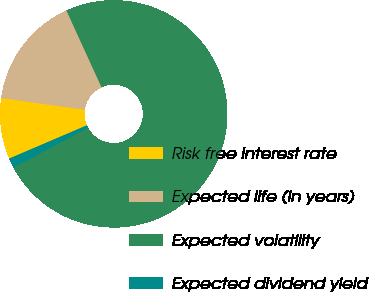<chart> <loc_0><loc_0><loc_500><loc_500><pie_chart><fcel>Risk free interest rate<fcel>Expected life (in years)<fcel>Expected volatility<fcel>Expected dividend yield<nl><fcel>8.67%<fcel>15.94%<fcel>73.98%<fcel>1.41%<nl></chart> 